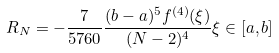<formula> <loc_0><loc_0><loc_500><loc_500>R _ { N } = - \frac { 7 } { 5 7 6 0 } \frac { ( b - a ) ^ { 5 } f ^ { ( 4 ) } ( \xi ) } { ( N - 2 ) ^ { 4 } } \xi \in [ a , b ]</formula> 